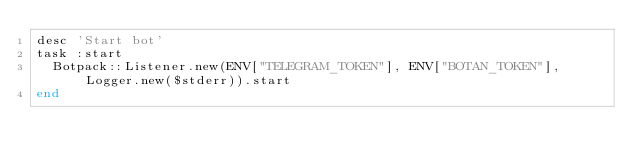Convert code to text. <code><loc_0><loc_0><loc_500><loc_500><_Ruby_>desc 'Start bot'
task :start
  Botpack::Listener.new(ENV["TELEGRAM_TOKEN"], ENV["BOTAN_TOKEN"], Logger.new($stderr)).start
end
</code> 